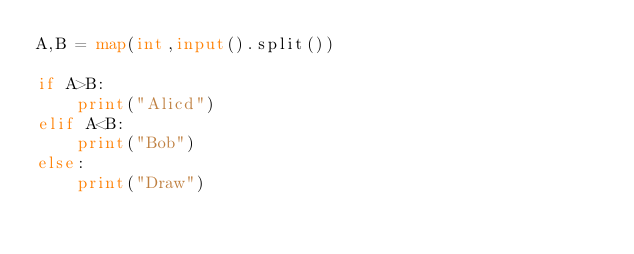<code> <loc_0><loc_0><loc_500><loc_500><_Python_>A,B = map(int,input().split())

if A>B:
    print("Alicd")
elif A<B:
    print("Bob")
else:
    print("Draw")</code> 